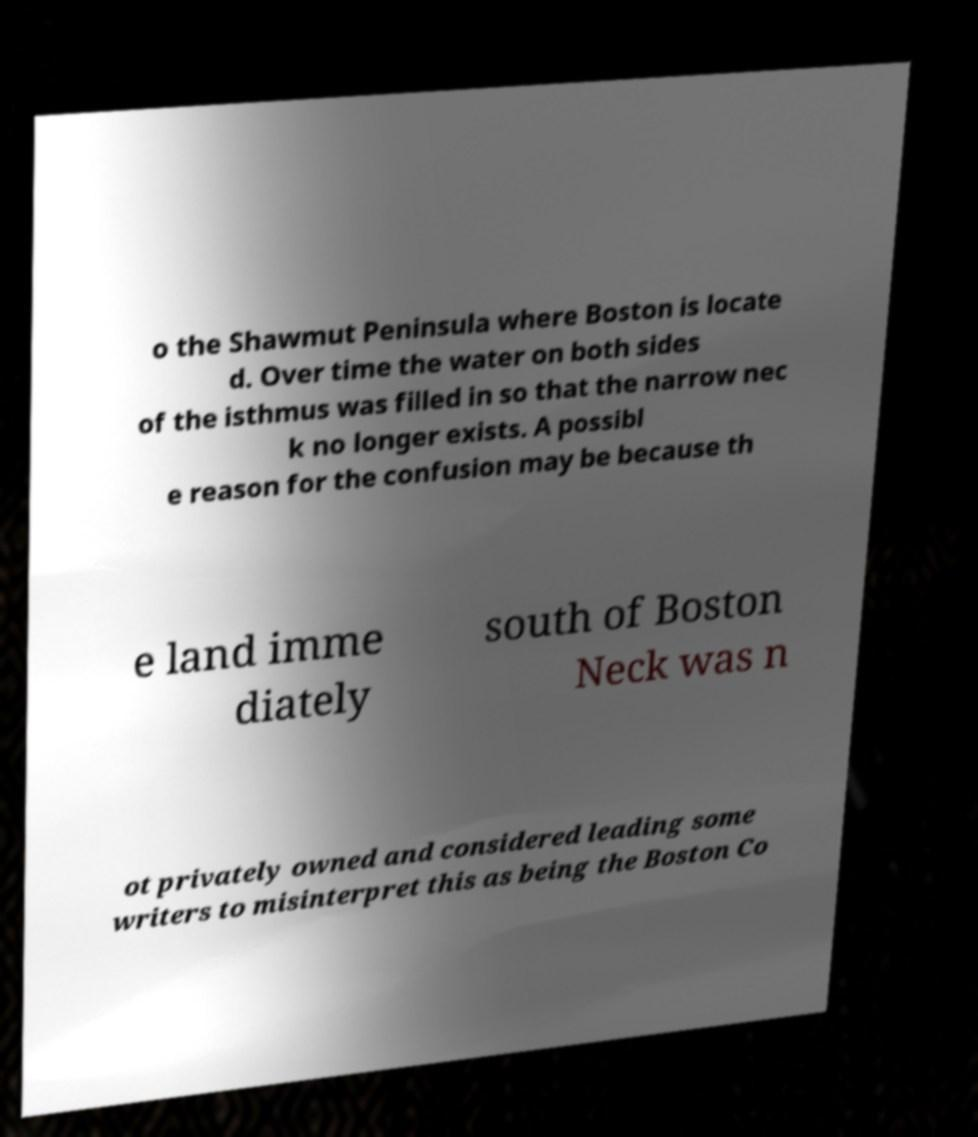Could you assist in decoding the text presented in this image and type it out clearly? o the Shawmut Peninsula where Boston is locate d. Over time the water on both sides of the isthmus was filled in so that the narrow nec k no longer exists. A possibl e reason for the confusion may be because th e land imme diately south of Boston Neck was n ot privately owned and considered leading some writers to misinterpret this as being the Boston Co 